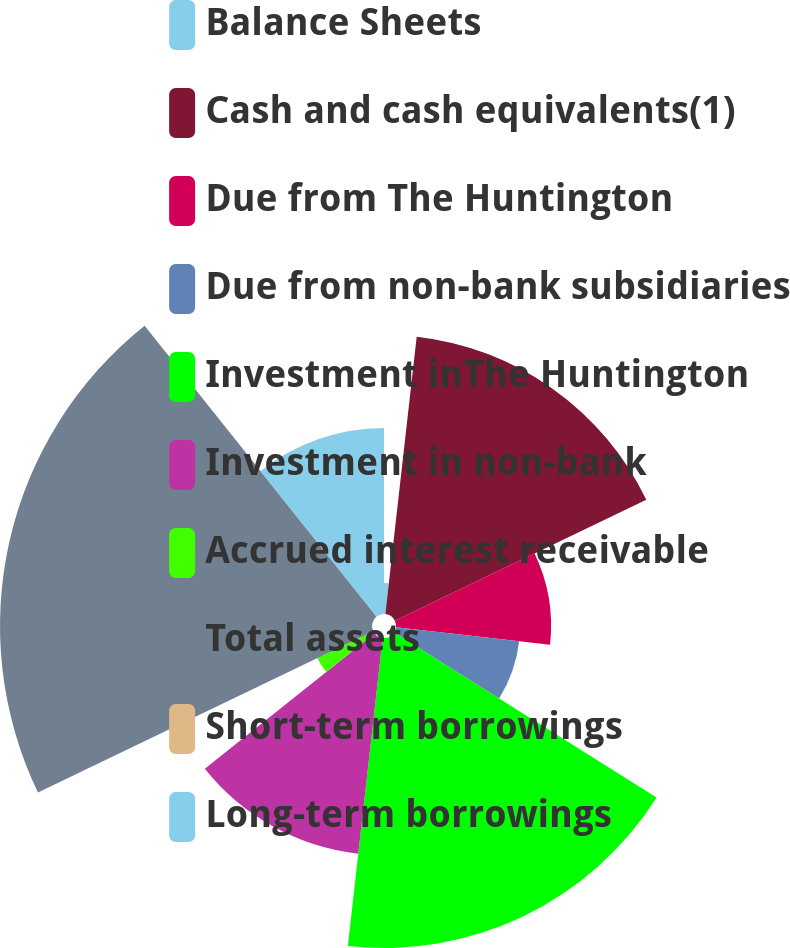Convert chart to OTSL. <chart><loc_0><loc_0><loc_500><loc_500><pie_chart><fcel>Balance Sheets<fcel>Cash and cash equivalents(1)<fcel>Due from The Huntington<fcel>Due from non-bank subsidiaries<fcel>Investment inThe Huntington<fcel>Investment in non-bank<fcel>Accrued interest receivable<fcel>Total assets<fcel>Short-term borrowings<fcel>Long-term borrowings<nl><fcel>1.79%<fcel>16.07%<fcel>8.93%<fcel>7.14%<fcel>17.85%<fcel>12.5%<fcel>3.57%<fcel>21.42%<fcel>0.0%<fcel>10.71%<nl></chart> 